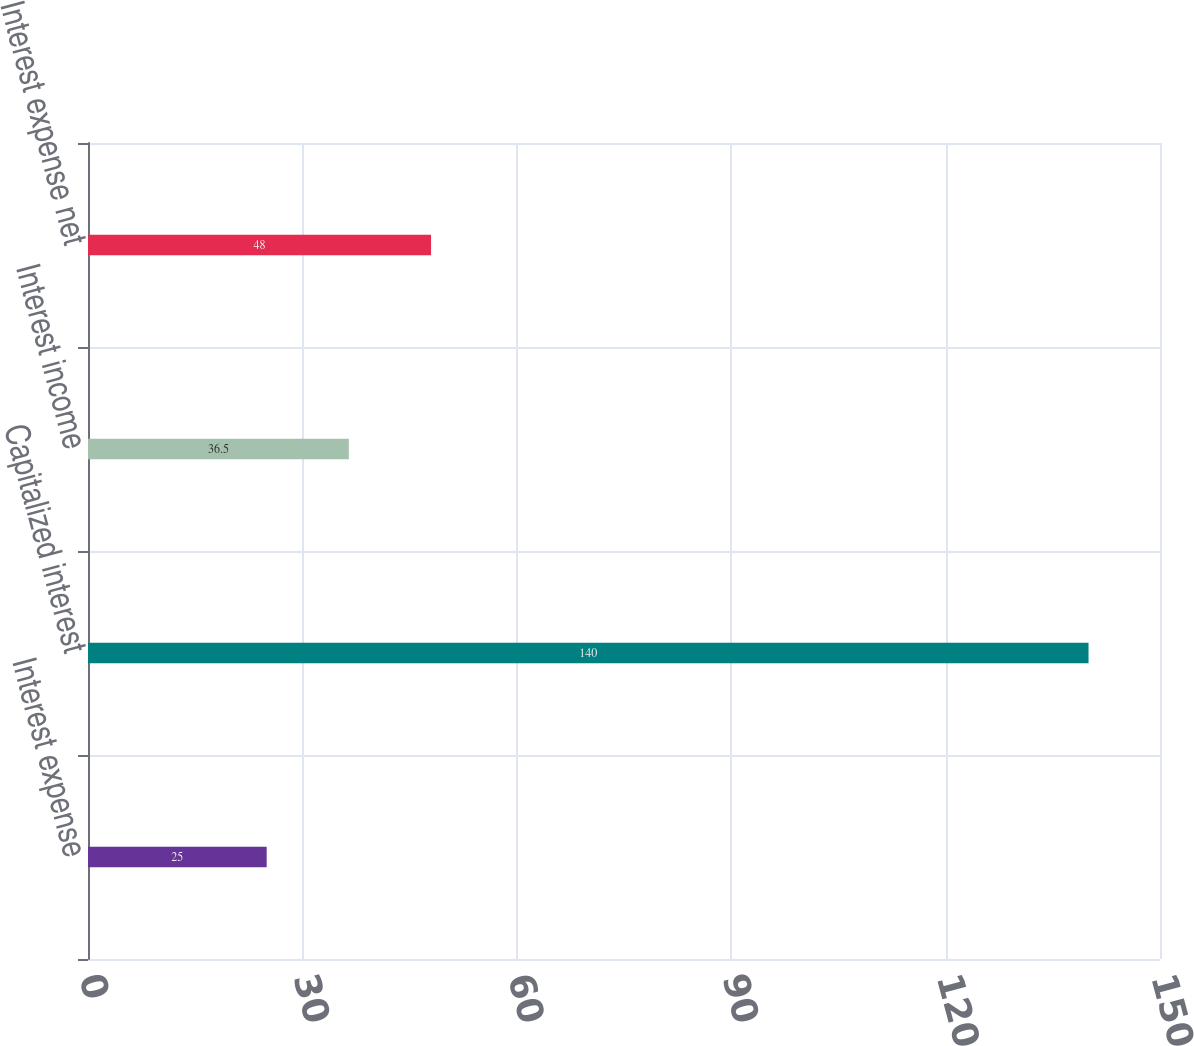Convert chart. <chart><loc_0><loc_0><loc_500><loc_500><bar_chart><fcel>Interest expense<fcel>Capitalized interest<fcel>Interest income<fcel>Interest expense net<nl><fcel>25<fcel>140<fcel>36.5<fcel>48<nl></chart> 